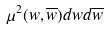<formula> <loc_0><loc_0><loc_500><loc_500>\mu ^ { 2 } ( w , \overline { w } ) d w d \overline { w }</formula> 